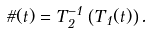Convert formula to latex. <formula><loc_0><loc_0><loc_500><loc_500>\vartheta ( t ) = T _ { 2 } ^ { - 1 } \left ( T _ { 1 } ( t ) \right ) .</formula> 